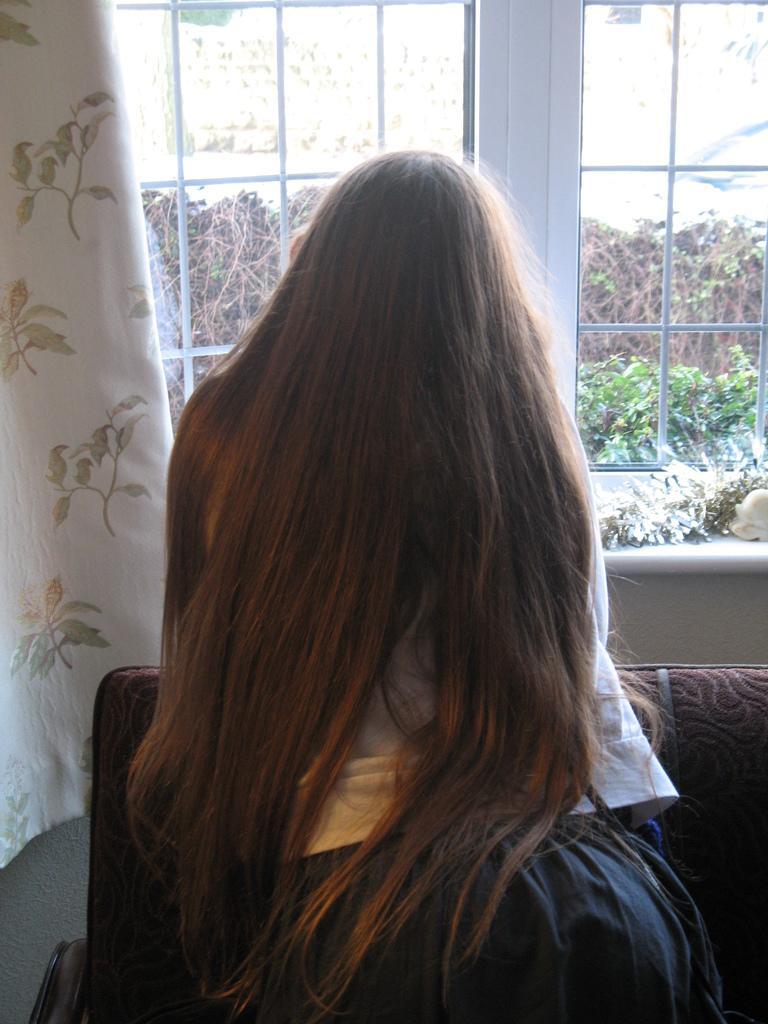Please provide a concise description of this image. In this image I can see the person. In-front of the person I can see the couch, curtains and the window. Through the window I can see many trees. 